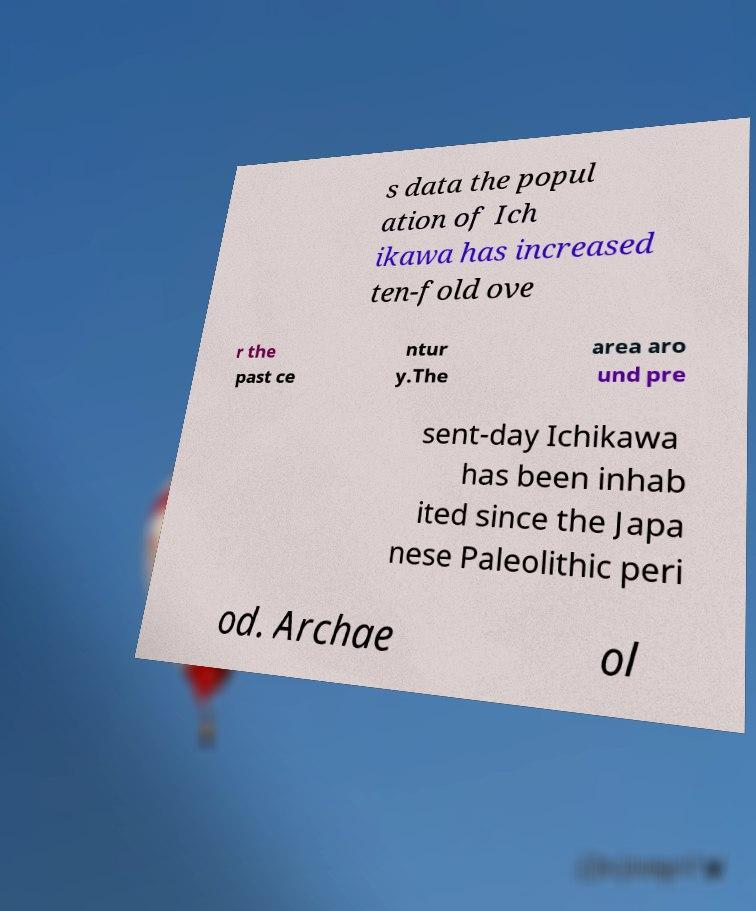Please read and relay the text visible in this image. What does it say? s data the popul ation of Ich ikawa has increased ten-fold ove r the past ce ntur y.The area aro und pre sent-day Ichikawa has been inhab ited since the Japa nese Paleolithic peri od. Archae ol 